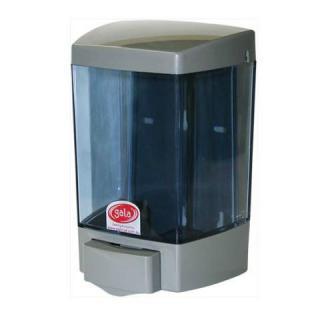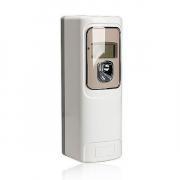The first image is the image on the left, the second image is the image on the right. Given the left and right images, does the statement "There are exactly three visible containers of soap, two in one image and one in the other." hold true? Answer yes or no. No. The first image is the image on the left, the second image is the image on the right. For the images displayed, is the sentence "There are more than two dispensers." factually correct? Answer yes or no. No. 